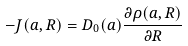<formula> <loc_0><loc_0><loc_500><loc_500>- J ( a , R ) = D _ { 0 } ( a ) \frac { \partial \rho ( a , R ) } { \partial R }</formula> 